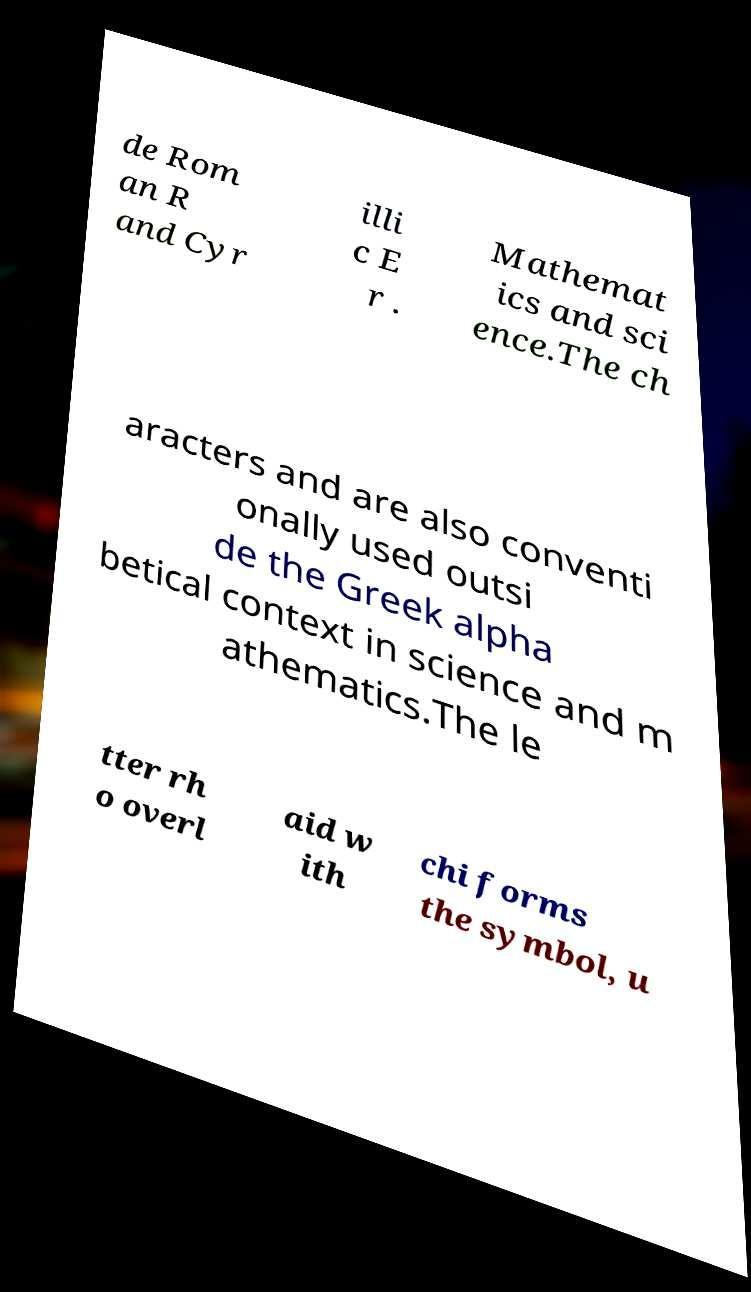Please identify and transcribe the text found in this image. de Rom an R and Cyr illi c E r . Mathemat ics and sci ence.The ch aracters and are also conventi onally used outsi de the Greek alpha betical context in science and m athematics.The le tter rh o overl aid w ith chi forms the symbol, u 